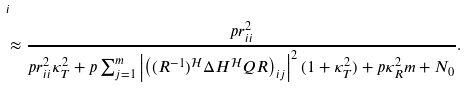<formula> <loc_0><loc_0><loc_500><loc_500>& _ { i } \\ & \approx \frac { p r ^ { 2 } _ { i i } } { p r ^ { 2 } _ { i i } \kappa ^ { 2 } _ { T } + p \sum ^ { m } _ { j = 1 } \left | \left ( ( R ^ { - 1 } ) ^ { \mathcal { H } } \Delta H ^ { \mathcal { H } } Q R \right ) _ { i j } \right | ^ { 2 } ( 1 + \kappa ^ { 2 } _ { T } ) + p \kappa ^ { 2 } _ { R } m + N _ { 0 } } .</formula> 